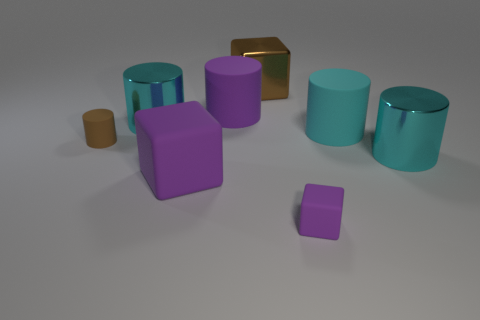Subtract all gray cubes. How many cyan cylinders are left? 3 Subtract all brown cylinders. How many cylinders are left? 4 Subtract all big purple cylinders. How many cylinders are left? 4 Add 1 large purple cylinders. How many objects exist? 9 Subtract all green cylinders. Subtract all yellow spheres. How many cylinders are left? 5 Subtract all cylinders. How many objects are left? 3 Add 8 big rubber cylinders. How many big rubber cylinders exist? 10 Subtract 0 green spheres. How many objects are left? 8 Subtract all cubes. Subtract all large rubber cylinders. How many objects are left? 3 Add 6 purple rubber cylinders. How many purple rubber cylinders are left? 7 